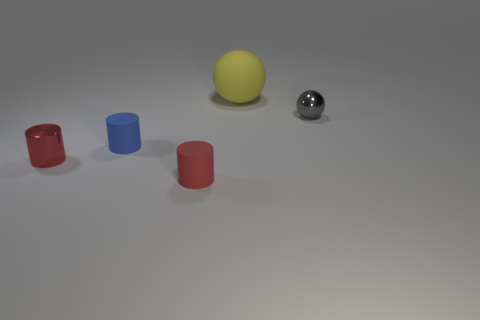How many other objects are there of the same material as the big yellow sphere?
Make the answer very short. 2. How many other things are the same color as the shiny cylinder?
Keep it short and to the point. 1. The tiny sphere is what color?
Keep it short and to the point. Gray. What size is the object that is both in front of the yellow matte ball and to the right of the red rubber thing?
Offer a terse response. Small. How many objects are either shiny things that are to the right of the yellow matte sphere or tiny objects?
Your answer should be compact. 4. The small red thing that is the same material as the tiny gray thing is what shape?
Give a very brief answer. Cylinder. The small red matte object is what shape?
Give a very brief answer. Cylinder. The rubber thing that is both in front of the gray metal thing and behind the red matte cylinder is what color?
Provide a short and direct response. Blue. The other red thing that is the same size as the red shiny thing is what shape?
Give a very brief answer. Cylinder. Are there any other big gray rubber objects that have the same shape as the gray object?
Your answer should be very brief. No. 